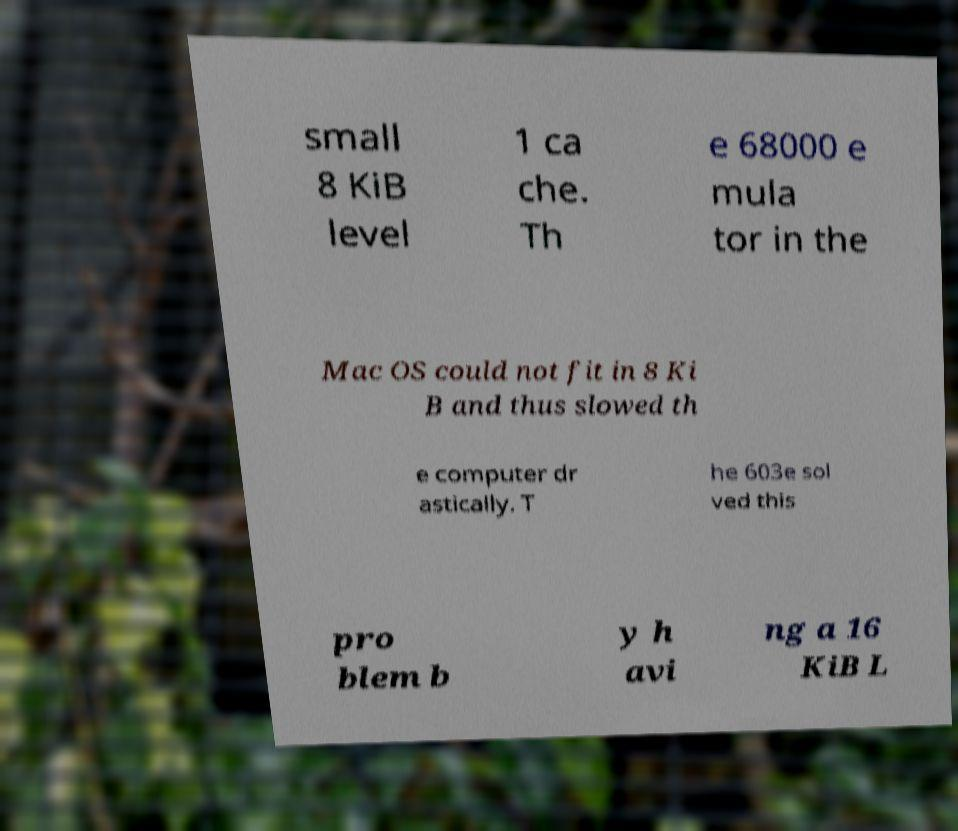There's text embedded in this image that I need extracted. Can you transcribe it verbatim? small 8 KiB level 1 ca che. Th e 68000 e mula tor in the Mac OS could not fit in 8 Ki B and thus slowed th e computer dr astically. T he 603e sol ved this pro blem b y h avi ng a 16 KiB L 